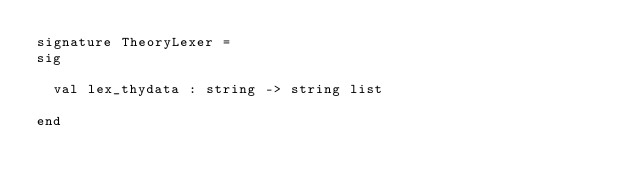Convert code to text. <code><loc_0><loc_0><loc_500><loc_500><_SML_>signature TheoryLexer =
sig

  val lex_thydata : string -> string list

end
</code> 